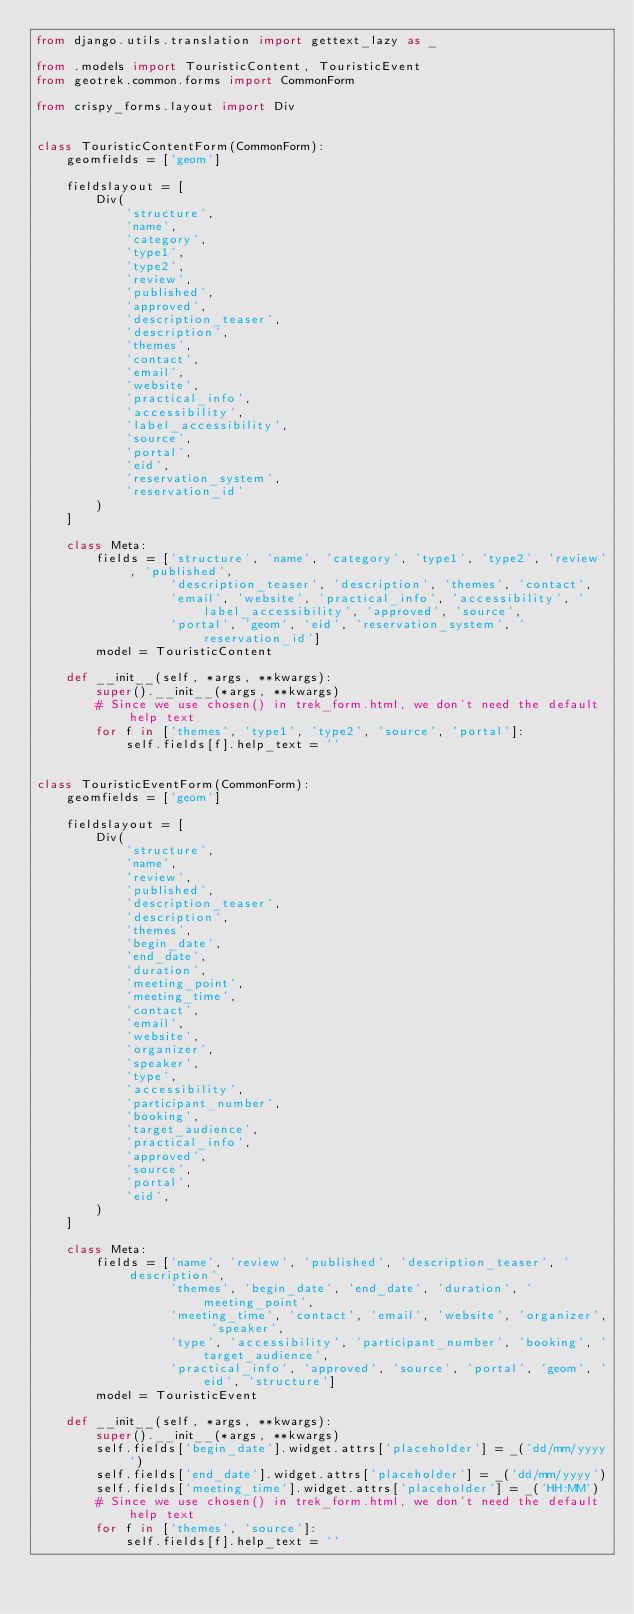Convert code to text. <code><loc_0><loc_0><loc_500><loc_500><_Python_>from django.utils.translation import gettext_lazy as _

from .models import TouristicContent, TouristicEvent
from geotrek.common.forms import CommonForm

from crispy_forms.layout import Div


class TouristicContentForm(CommonForm):
    geomfields = ['geom']

    fieldslayout = [
        Div(
            'structure',
            'name',
            'category',
            'type1',
            'type2',
            'review',
            'published',
            'approved',
            'description_teaser',
            'description',
            'themes',
            'contact',
            'email',
            'website',
            'practical_info',
            'accessibility',
            'label_accessibility',
            'source',
            'portal',
            'eid',
            'reservation_system',
            'reservation_id'
        )
    ]

    class Meta:
        fields = ['structure', 'name', 'category', 'type1', 'type2', 'review', 'published',
                  'description_teaser', 'description', 'themes', 'contact',
                  'email', 'website', 'practical_info', 'accessibility', 'label_accessibility', 'approved', 'source',
                  'portal', 'geom', 'eid', 'reservation_system', 'reservation_id']
        model = TouristicContent

    def __init__(self, *args, **kwargs):
        super().__init__(*args, **kwargs)
        # Since we use chosen() in trek_form.html, we don't need the default help text
        for f in ['themes', 'type1', 'type2', 'source', 'portal']:
            self.fields[f].help_text = ''


class TouristicEventForm(CommonForm):
    geomfields = ['geom']

    fieldslayout = [
        Div(
            'structure',
            'name',
            'review',
            'published',
            'description_teaser',
            'description',
            'themes',
            'begin_date',
            'end_date',
            'duration',
            'meeting_point',
            'meeting_time',
            'contact',
            'email',
            'website',
            'organizer',
            'speaker',
            'type',
            'accessibility',
            'participant_number',
            'booking',
            'target_audience',
            'practical_info',
            'approved',
            'source',
            'portal',
            'eid',
        )
    ]

    class Meta:
        fields = ['name', 'review', 'published', 'description_teaser', 'description',
                  'themes', 'begin_date', 'end_date', 'duration', 'meeting_point',
                  'meeting_time', 'contact', 'email', 'website', 'organizer', 'speaker',
                  'type', 'accessibility', 'participant_number', 'booking', 'target_audience',
                  'practical_info', 'approved', 'source', 'portal', 'geom', 'eid', 'structure']
        model = TouristicEvent

    def __init__(self, *args, **kwargs):
        super().__init__(*args, **kwargs)
        self.fields['begin_date'].widget.attrs['placeholder'] = _('dd/mm/yyyy')
        self.fields['end_date'].widget.attrs['placeholder'] = _('dd/mm/yyyy')
        self.fields['meeting_time'].widget.attrs['placeholder'] = _('HH:MM')
        # Since we use chosen() in trek_form.html, we don't need the default help text
        for f in ['themes', 'source']:
            self.fields[f].help_text = ''
</code> 